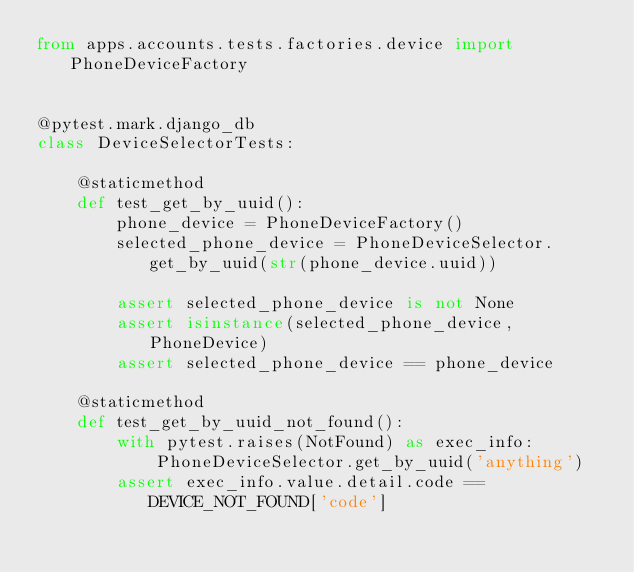<code> <loc_0><loc_0><loc_500><loc_500><_Python_>from apps.accounts.tests.factories.device import PhoneDeviceFactory


@pytest.mark.django_db
class DeviceSelectorTests:

    @staticmethod
    def test_get_by_uuid():
        phone_device = PhoneDeviceFactory()
        selected_phone_device = PhoneDeviceSelector.get_by_uuid(str(phone_device.uuid))

        assert selected_phone_device is not None
        assert isinstance(selected_phone_device, PhoneDevice)
        assert selected_phone_device == phone_device

    @staticmethod
    def test_get_by_uuid_not_found():
        with pytest.raises(NotFound) as exec_info:
            PhoneDeviceSelector.get_by_uuid('anything')
        assert exec_info.value.detail.code == DEVICE_NOT_FOUND['code']

</code> 